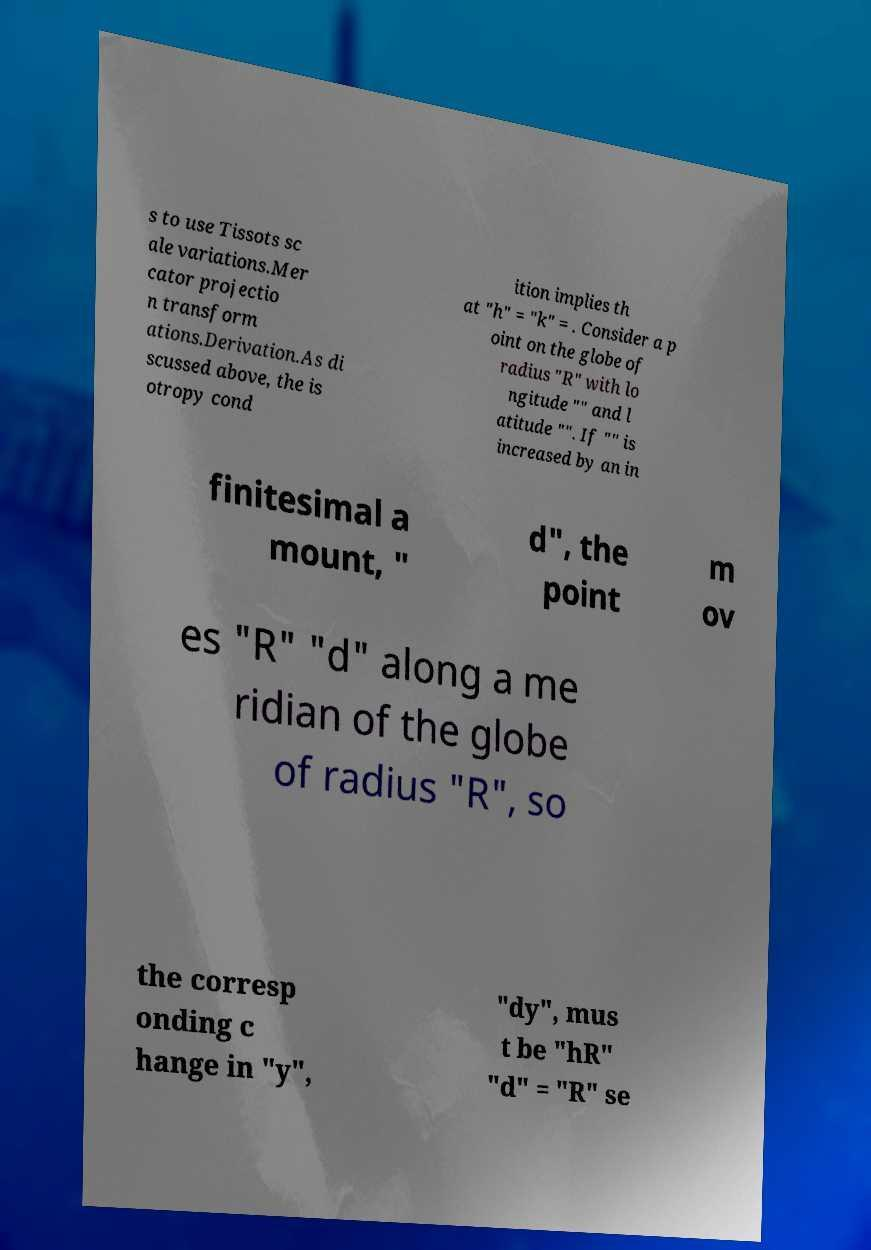What messages or text are displayed in this image? I need them in a readable, typed format. s to use Tissots sc ale variations.Mer cator projectio n transform ations.Derivation.As di scussed above, the is otropy cond ition implies th at "h" = "k" = . Consider a p oint on the globe of radius "R" with lo ngitude "" and l atitude "". If "" is increased by an in finitesimal a mount, " d", the point m ov es "R" "d" along a me ridian of the globe of radius "R", so the corresp onding c hange in "y", "dy", mus t be "hR" "d" = "R" se 